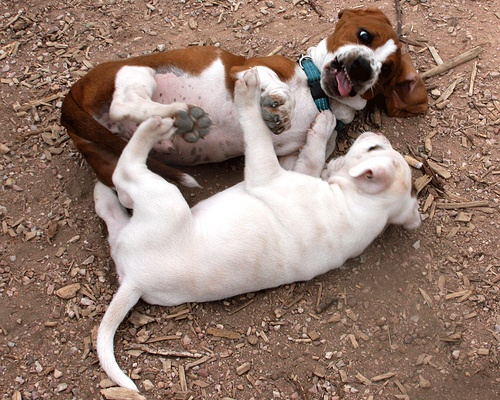Describe the objects in this image and their specific colors. I can see dog in tan, lightgray, and darkgray tones and dog in tan, lightgray, black, maroon, and gray tones in this image. 